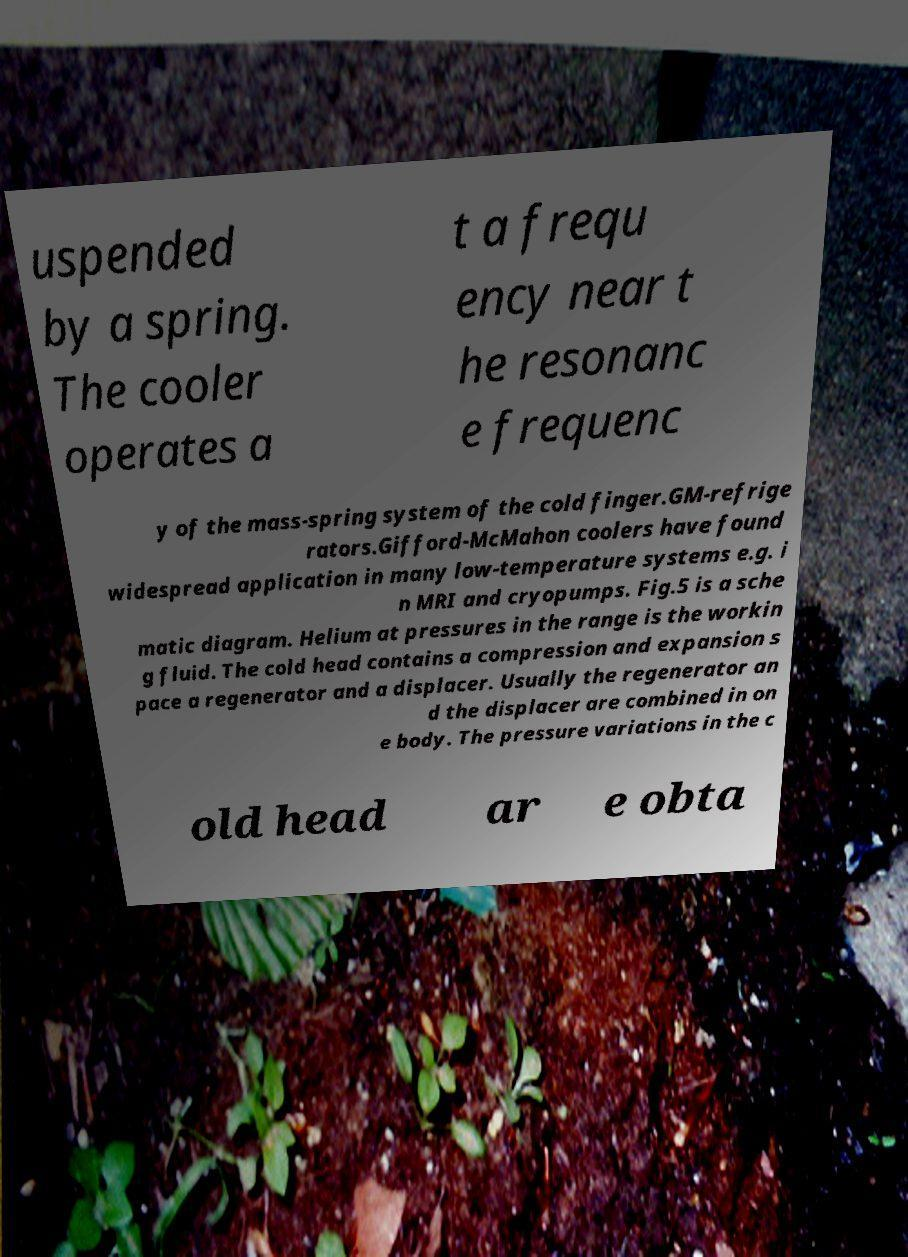There's text embedded in this image that I need extracted. Can you transcribe it verbatim? uspended by a spring. The cooler operates a t a frequ ency near t he resonanc e frequenc y of the mass-spring system of the cold finger.GM-refrige rators.Gifford-McMahon coolers have found widespread application in many low-temperature systems e.g. i n MRI and cryopumps. Fig.5 is a sche matic diagram. Helium at pressures in the range is the workin g fluid. The cold head contains a compression and expansion s pace a regenerator and a displacer. Usually the regenerator an d the displacer are combined in on e body. The pressure variations in the c old head ar e obta 